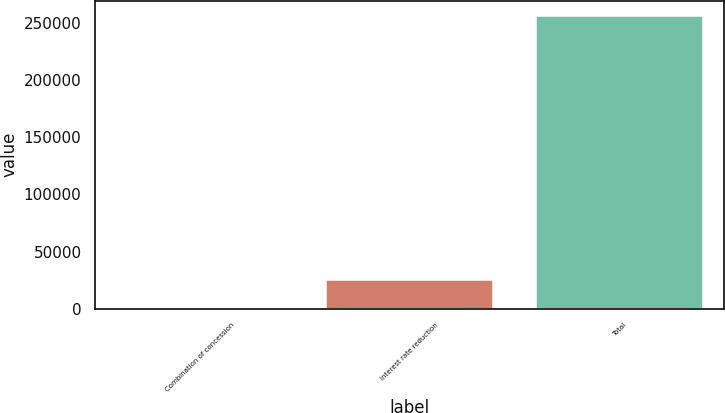Convert chart. <chart><loc_0><loc_0><loc_500><loc_500><bar_chart><fcel>Combination of concession<fcel>Interest rate reduction<fcel>Total<nl><fcel>628<fcel>26233.3<fcel>256681<nl></chart> 